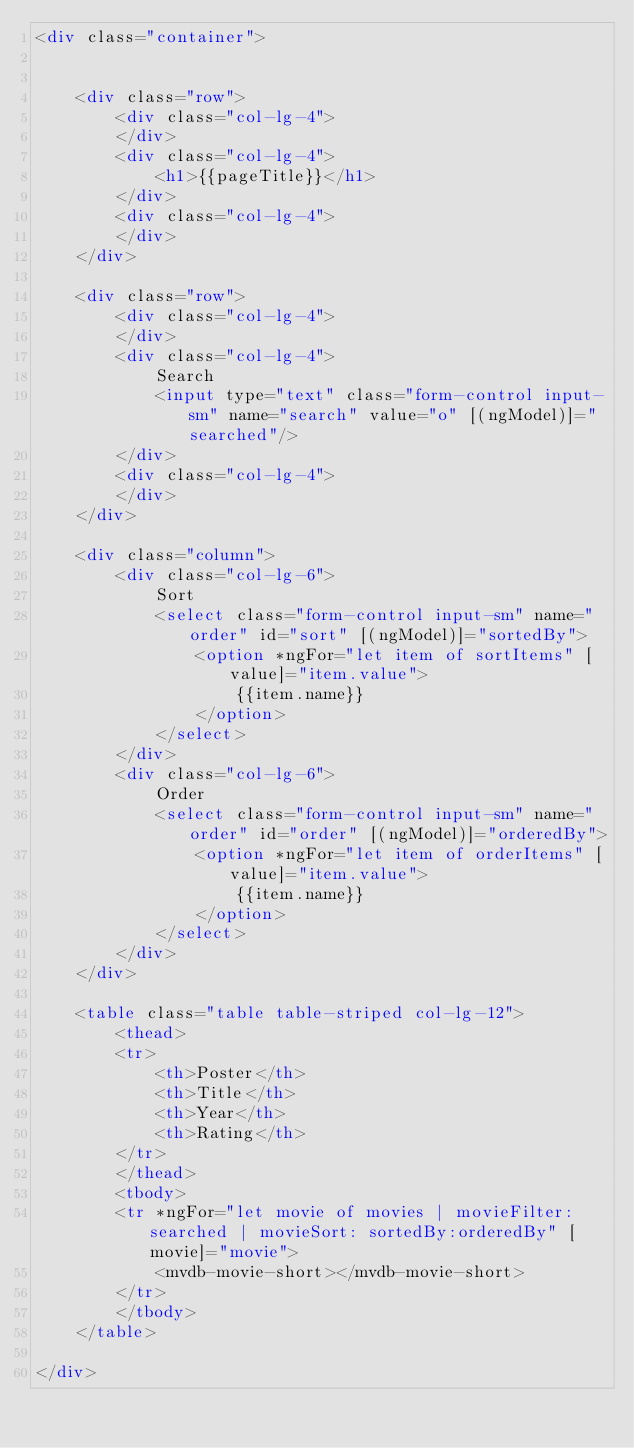<code> <loc_0><loc_0><loc_500><loc_500><_HTML_><div class="container">


    <div class="row">
        <div class="col-lg-4">
        </div>
        <div class="col-lg-4">
            <h1>{{pageTitle}}</h1>
        </div>
        <div class="col-lg-4">
        </div>
    </div>

    <div class="row">
        <div class="col-lg-4">
        </div>
        <div class="col-lg-4">
            Search
            <input type="text" class="form-control input-sm" name="search" value="o" [(ngModel)]="searched"/>
        </div>
        <div class="col-lg-4">
        </div>
    </div>

    <div class="column">
        <div class="col-lg-6">
            Sort
            <select class="form-control input-sm" name="order" id="sort" [(ngModel)]="sortedBy">
                <option *ngFor="let item of sortItems" [value]="item.value">
                    {{item.name}}
                </option>
            </select>
        </div>
        <div class="col-lg-6">
            Order
            <select class="form-control input-sm" name="order" id="order" [(ngModel)]="orderedBy">
                <option *ngFor="let item of orderItems" [value]="item.value">
                    {{item.name}}
                </option>
            </select>
        </div>
    </div>

    <table class="table table-striped col-lg-12">
        <thead>
        <tr>
            <th>Poster</th>
            <th>Title</th>
            <th>Year</th>
            <th>Rating</th>
        </tr>
        </thead>
        <tbody>
        <tr *ngFor="let movie of movies | movieFilter: searched | movieSort: sortedBy:orderedBy" [movie]="movie">
            <mvdb-movie-short></mvdb-movie-short>
        </tr>
        </tbody>
    </table>

</div></code> 